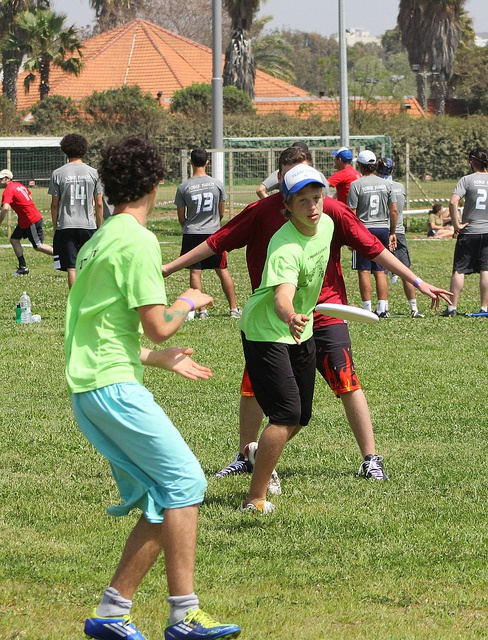Describe the objects in this image and their specific colors. I can see people in tan, beige, green, khaki, and black tones, people in tan, black, olive, green, and beige tones, people in tan, black, maroon, and gray tones, people in tan, black, darkgray, gray, and lightgray tones, and people in tan, black, gray, darkgray, and lightgray tones in this image. 